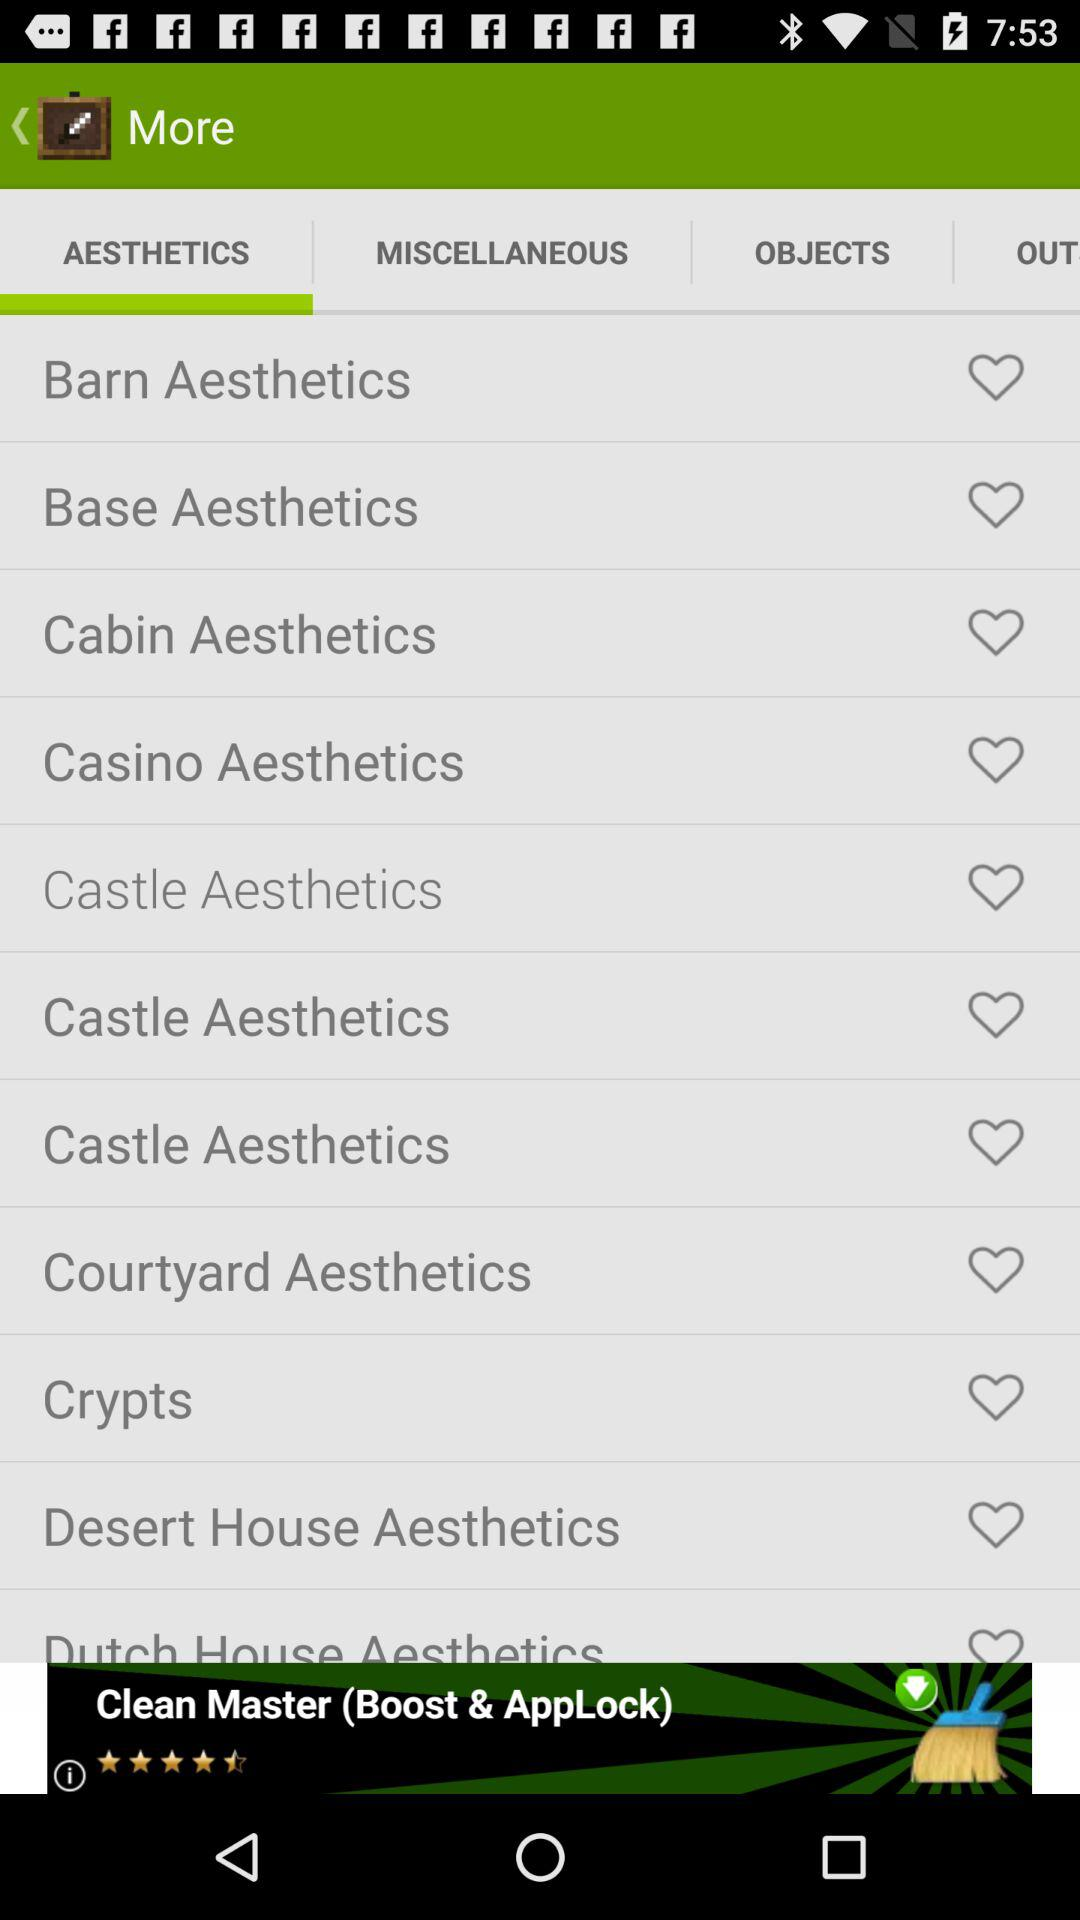Which tab is selected? The selected tab is "AESTHETICS". 